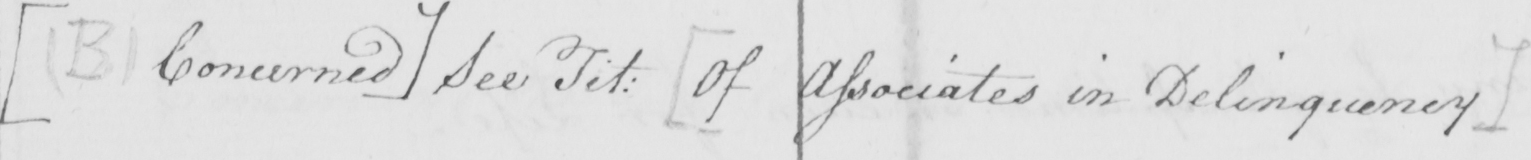What does this handwritten line say? [  ( B )  Concerned ]  See Tit :   [ Of Associates in Delinquency ] 